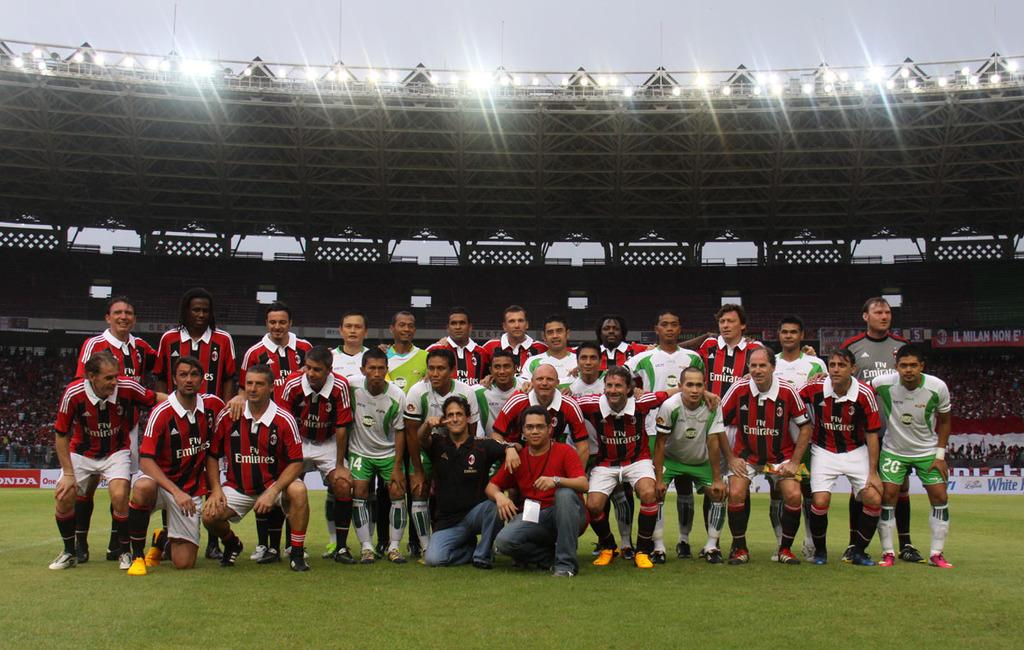What is the main structure visible in the image? There is a stadium in the image. What are the people in the image wearing? The persons in the image are wearing clothes. What can be seen at the top of the image? There are lights at the top of the image. What type of fog can be seen surrounding the stadium in the image? There is no fog present in the image; the stadium and the people are clearly visible. 